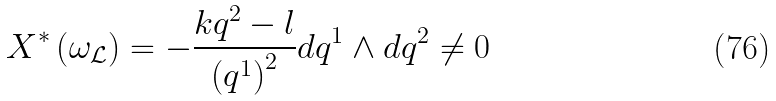Convert formula to latex. <formula><loc_0><loc_0><loc_500><loc_500>X ^ { \ast } \left ( \omega _ { \mathcal { L } } \right ) = - \frac { k q ^ { 2 } - l } { \left ( q ^ { 1 } \right ) ^ { 2 } } d q ^ { 1 } \wedge d q ^ { 2 } \neq 0</formula> 